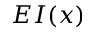Convert formula to latex. <formula><loc_0><loc_0><loc_500><loc_500>E I ( x )</formula> 